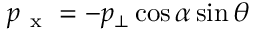<formula> <loc_0><loc_0><loc_500><loc_500>p _ { x } = - p _ { \bot } \cos { \alpha } \sin { \theta }</formula> 